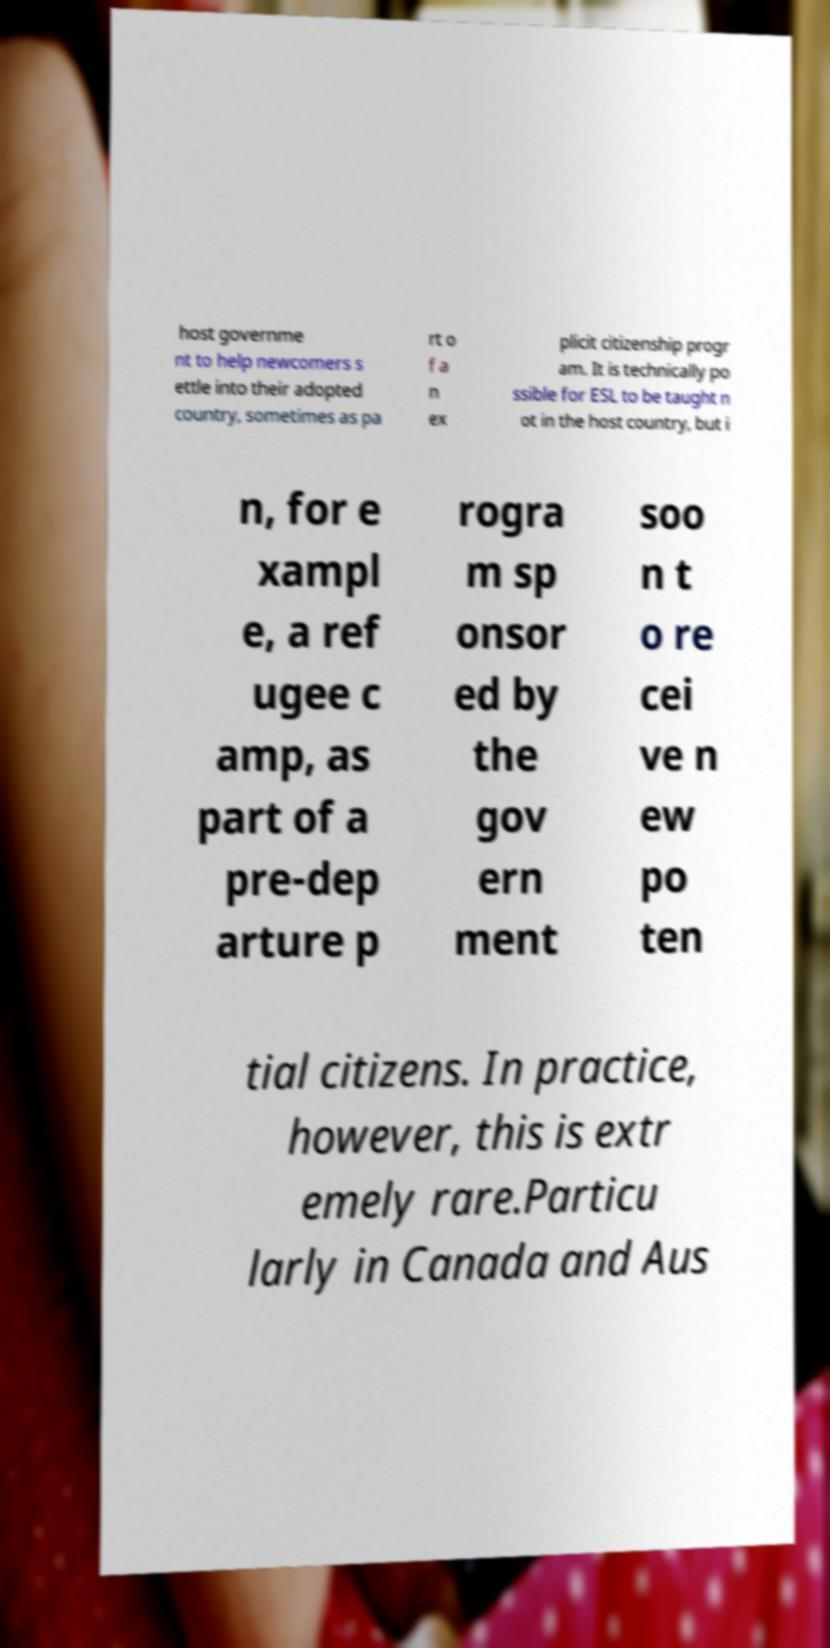Please identify and transcribe the text found in this image. host governme nt to help newcomers s ettle into their adopted country, sometimes as pa rt o f a n ex plicit citizenship progr am. It is technically po ssible for ESL to be taught n ot in the host country, but i n, for e xampl e, a ref ugee c amp, as part of a pre-dep arture p rogra m sp onsor ed by the gov ern ment soo n t o re cei ve n ew po ten tial citizens. In practice, however, this is extr emely rare.Particu larly in Canada and Aus 